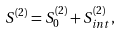Convert formula to latex. <formula><loc_0><loc_0><loc_500><loc_500>S ^ { ( 2 ) } = S ^ { ( 2 ) } _ { 0 } + S ^ { ( 2 ) } _ { i n t } ,</formula> 